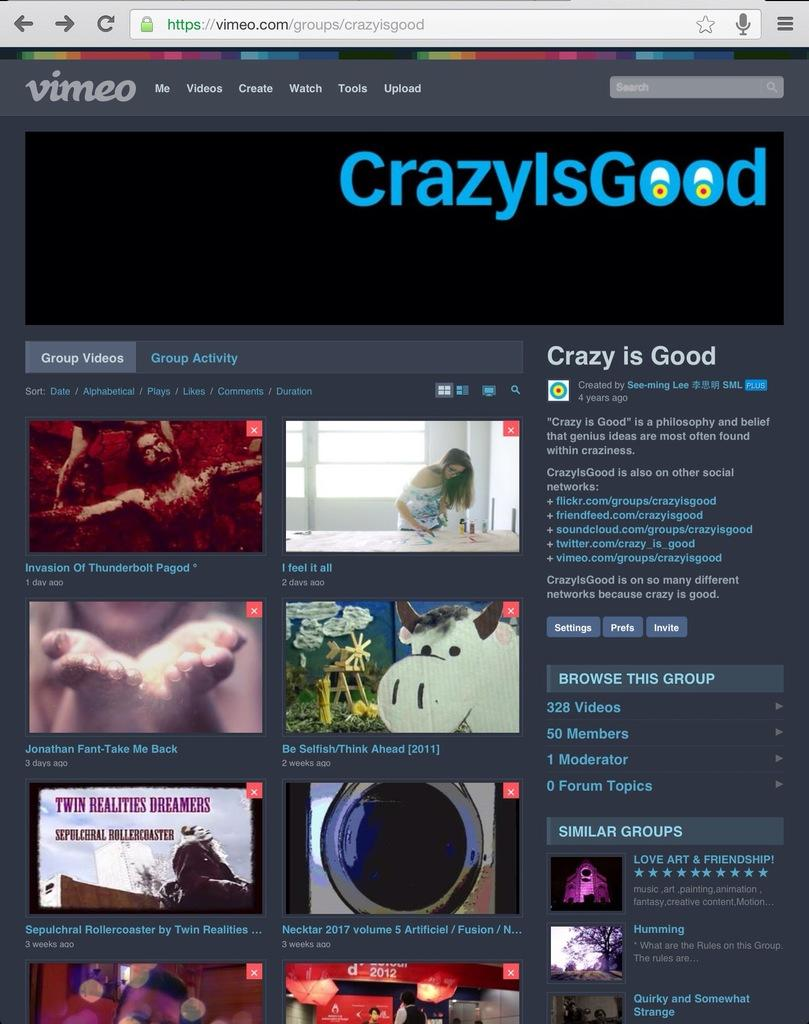<image>
Share a concise interpretation of the image provided. a crazy is good site with videos on it 